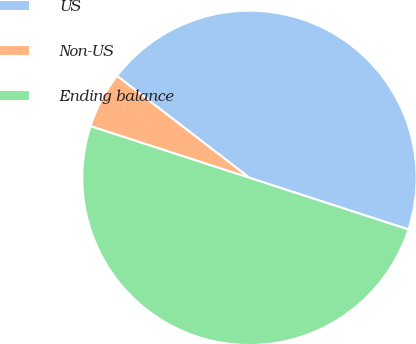Convert chart. <chart><loc_0><loc_0><loc_500><loc_500><pie_chart><fcel>US<fcel>Non-US<fcel>Ending balance<nl><fcel>44.56%<fcel>5.44%<fcel>50.0%<nl></chart> 